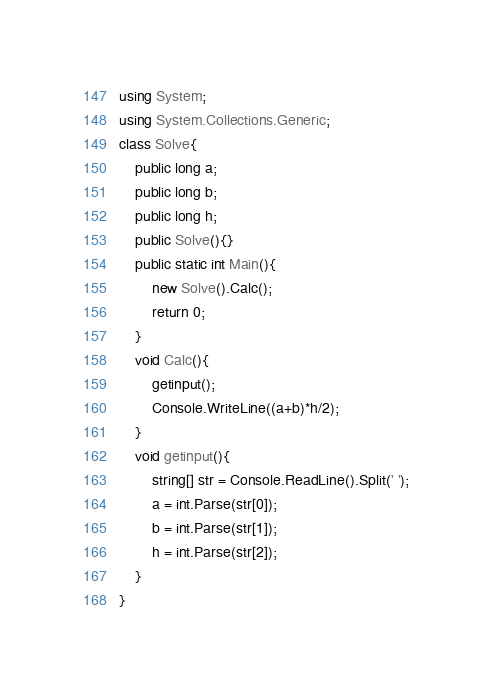<code> <loc_0><loc_0><loc_500><loc_500><_C#_>using System;
using System.Collections.Generic;
class Solve{
    public long a;
    public long b;
    public long h;
    public Solve(){}
    public static int Main(){
        new Solve().Calc();
        return 0;
    }
    void Calc(){
        getinput();
        Console.WriteLine((a+b)*h/2);
    }
    void getinput(){
        string[] str = Console.ReadLine().Split(' ');
        a = int.Parse(str[0]);
        b = int.Parse(str[1]);
        h = int.Parse(str[2]);
    }    
}</code> 